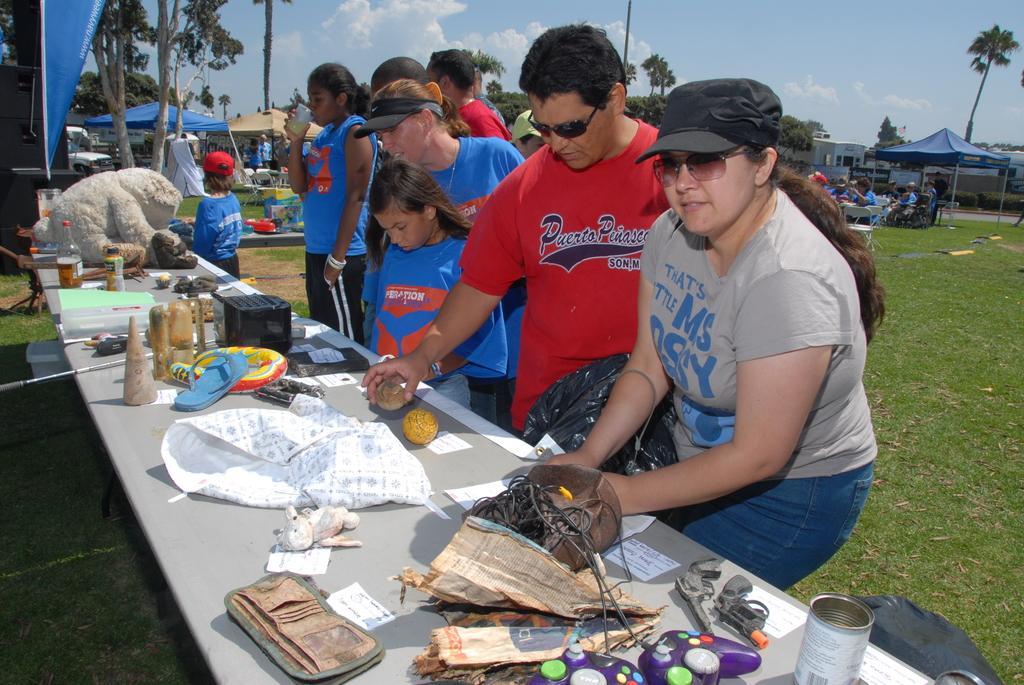How would you summarize this image in a sentence or two? In this picture there are group of people standing behind the table and holding the objects. There are bags, bottles, papers, devices and there is a toy, footwear on the table. At the back there are buildings, trees and tents and there are group of people sitting and there are tables and chairs. At the top there is sky and there are clouds. At the bottom there is grass. 